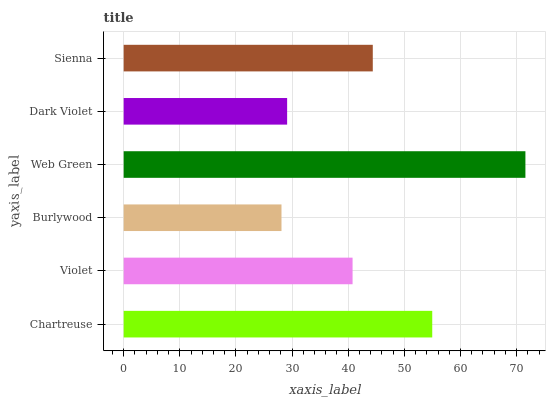Is Burlywood the minimum?
Answer yes or no. Yes. Is Web Green the maximum?
Answer yes or no. Yes. Is Violet the minimum?
Answer yes or no. No. Is Violet the maximum?
Answer yes or no. No. Is Chartreuse greater than Violet?
Answer yes or no. Yes. Is Violet less than Chartreuse?
Answer yes or no. Yes. Is Violet greater than Chartreuse?
Answer yes or no. No. Is Chartreuse less than Violet?
Answer yes or no. No. Is Sienna the high median?
Answer yes or no. Yes. Is Violet the low median?
Answer yes or no. Yes. Is Web Green the high median?
Answer yes or no. No. Is Chartreuse the low median?
Answer yes or no. No. 